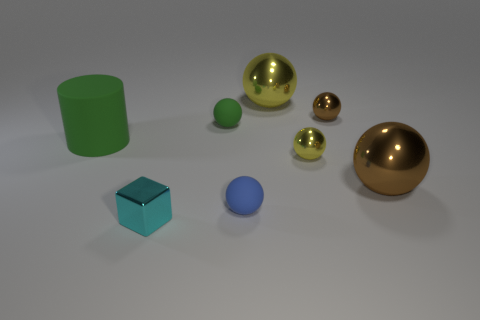There is a cyan object that is the same size as the blue sphere; what is it made of?
Offer a very short reply. Metal. There is a tiny shiny object behind the green matte cylinder behind the blue rubber ball that is in front of the big yellow sphere; what is its shape?
Provide a succinct answer. Sphere. The green thing that is the same size as the cyan metal block is what shape?
Provide a short and direct response. Sphere. There is a tiny matte thing that is in front of the green matte object that is right of the shiny block; what number of small blue rubber balls are to the right of it?
Your response must be concise. 0. Is the number of large metallic things in front of the tiny blue thing greater than the number of large green rubber objects to the right of the block?
Ensure brevity in your answer.  No. How many other big things are the same shape as the large yellow object?
Your response must be concise. 1. What number of things are either small rubber objects to the left of the blue object or green objects that are behind the cylinder?
Offer a terse response. 1. There is a large ball that is left of the brown thing that is behind the large metal sphere that is to the right of the small brown thing; what is it made of?
Your answer should be compact. Metal. Does the tiny rubber sphere that is behind the large cylinder have the same color as the large cylinder?
Ensure brevity in your answer.  Yes. There is a small thing that is to the left of the blue rubber ball and to the right of the cyan thing; what material is it made of?
Provide a short and direct response. Rubber. 